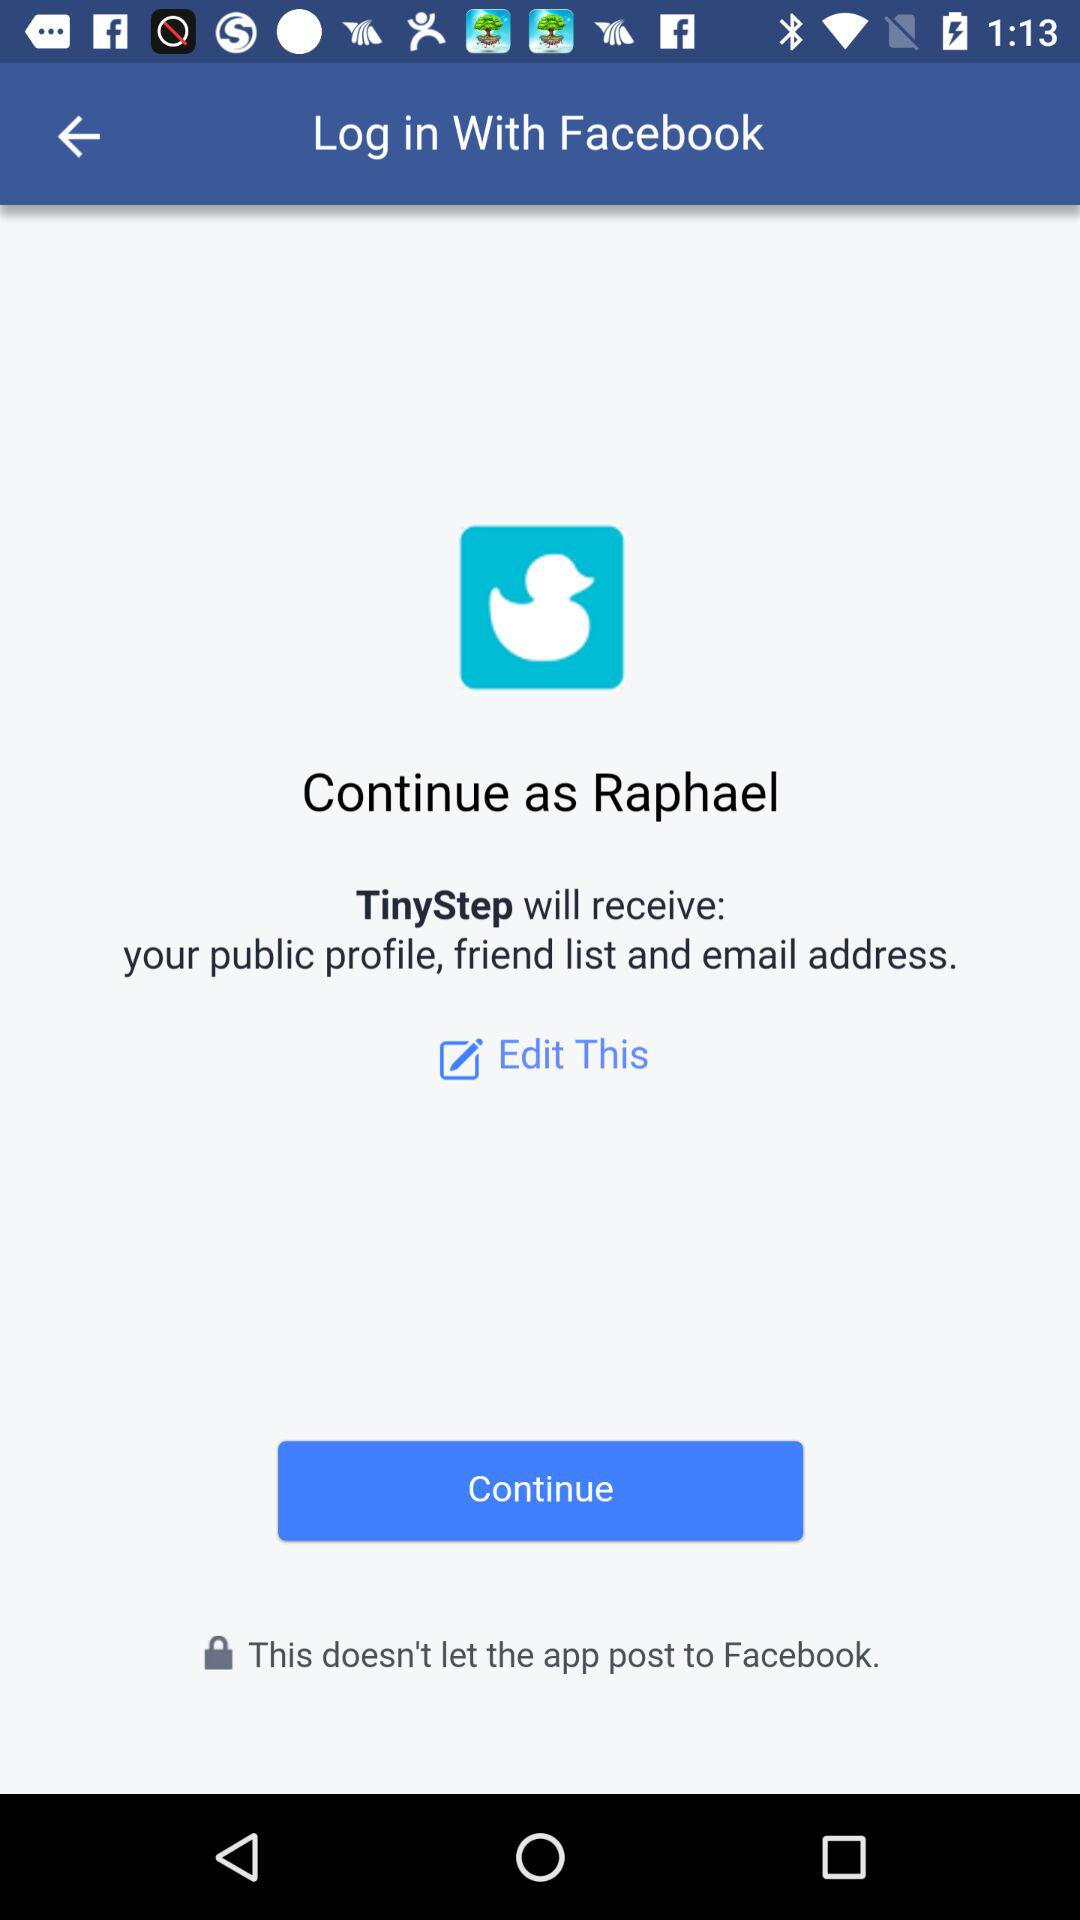Who developed the application "TinyStep"?
When the provided information is insufficient, respond with <no answer>. <no answer> 